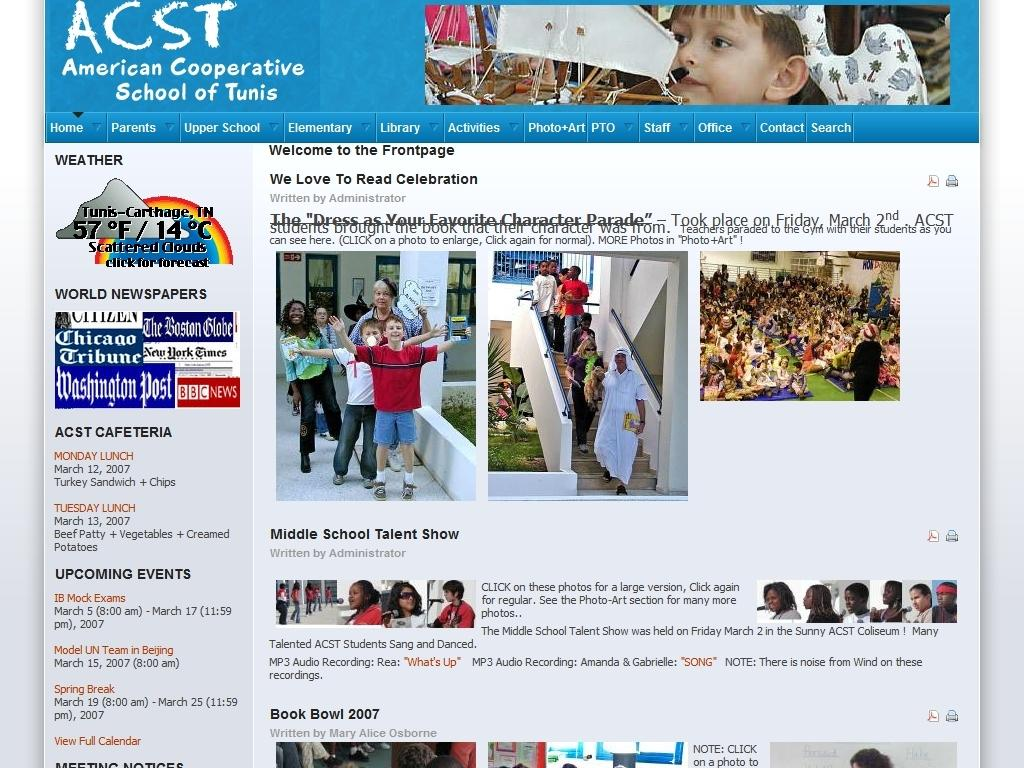What type of image is being described? The image is a screenshot of a website. What can be found on the website? The website contains text and images of people. How many cows are visible on the website in the image? There are no cows visible on the website in the image. 